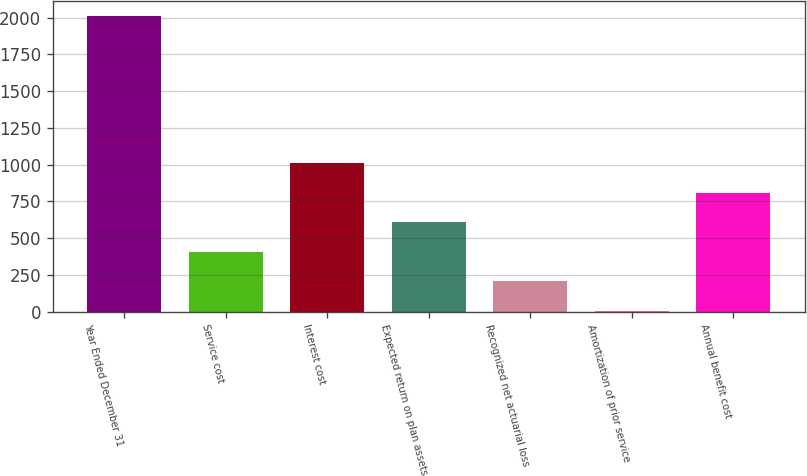Convert chart. <chart><loc_0><loc_0><loc_500><loc_500><bar_chart><fcel>Year Ended December 31<fcel>Service cost<fcel>Interest cost<fcel>Expected return on plan assets<fcel>Recognized net actuarial loss<fcel>Amortization of prior service<fcel>Annual benefit cost<nl><fcel>2012<fcel>408<fcel>1009.5<fcel>608.5<fcel>207.5<fcel>7<fcel>809<nl></chart> 